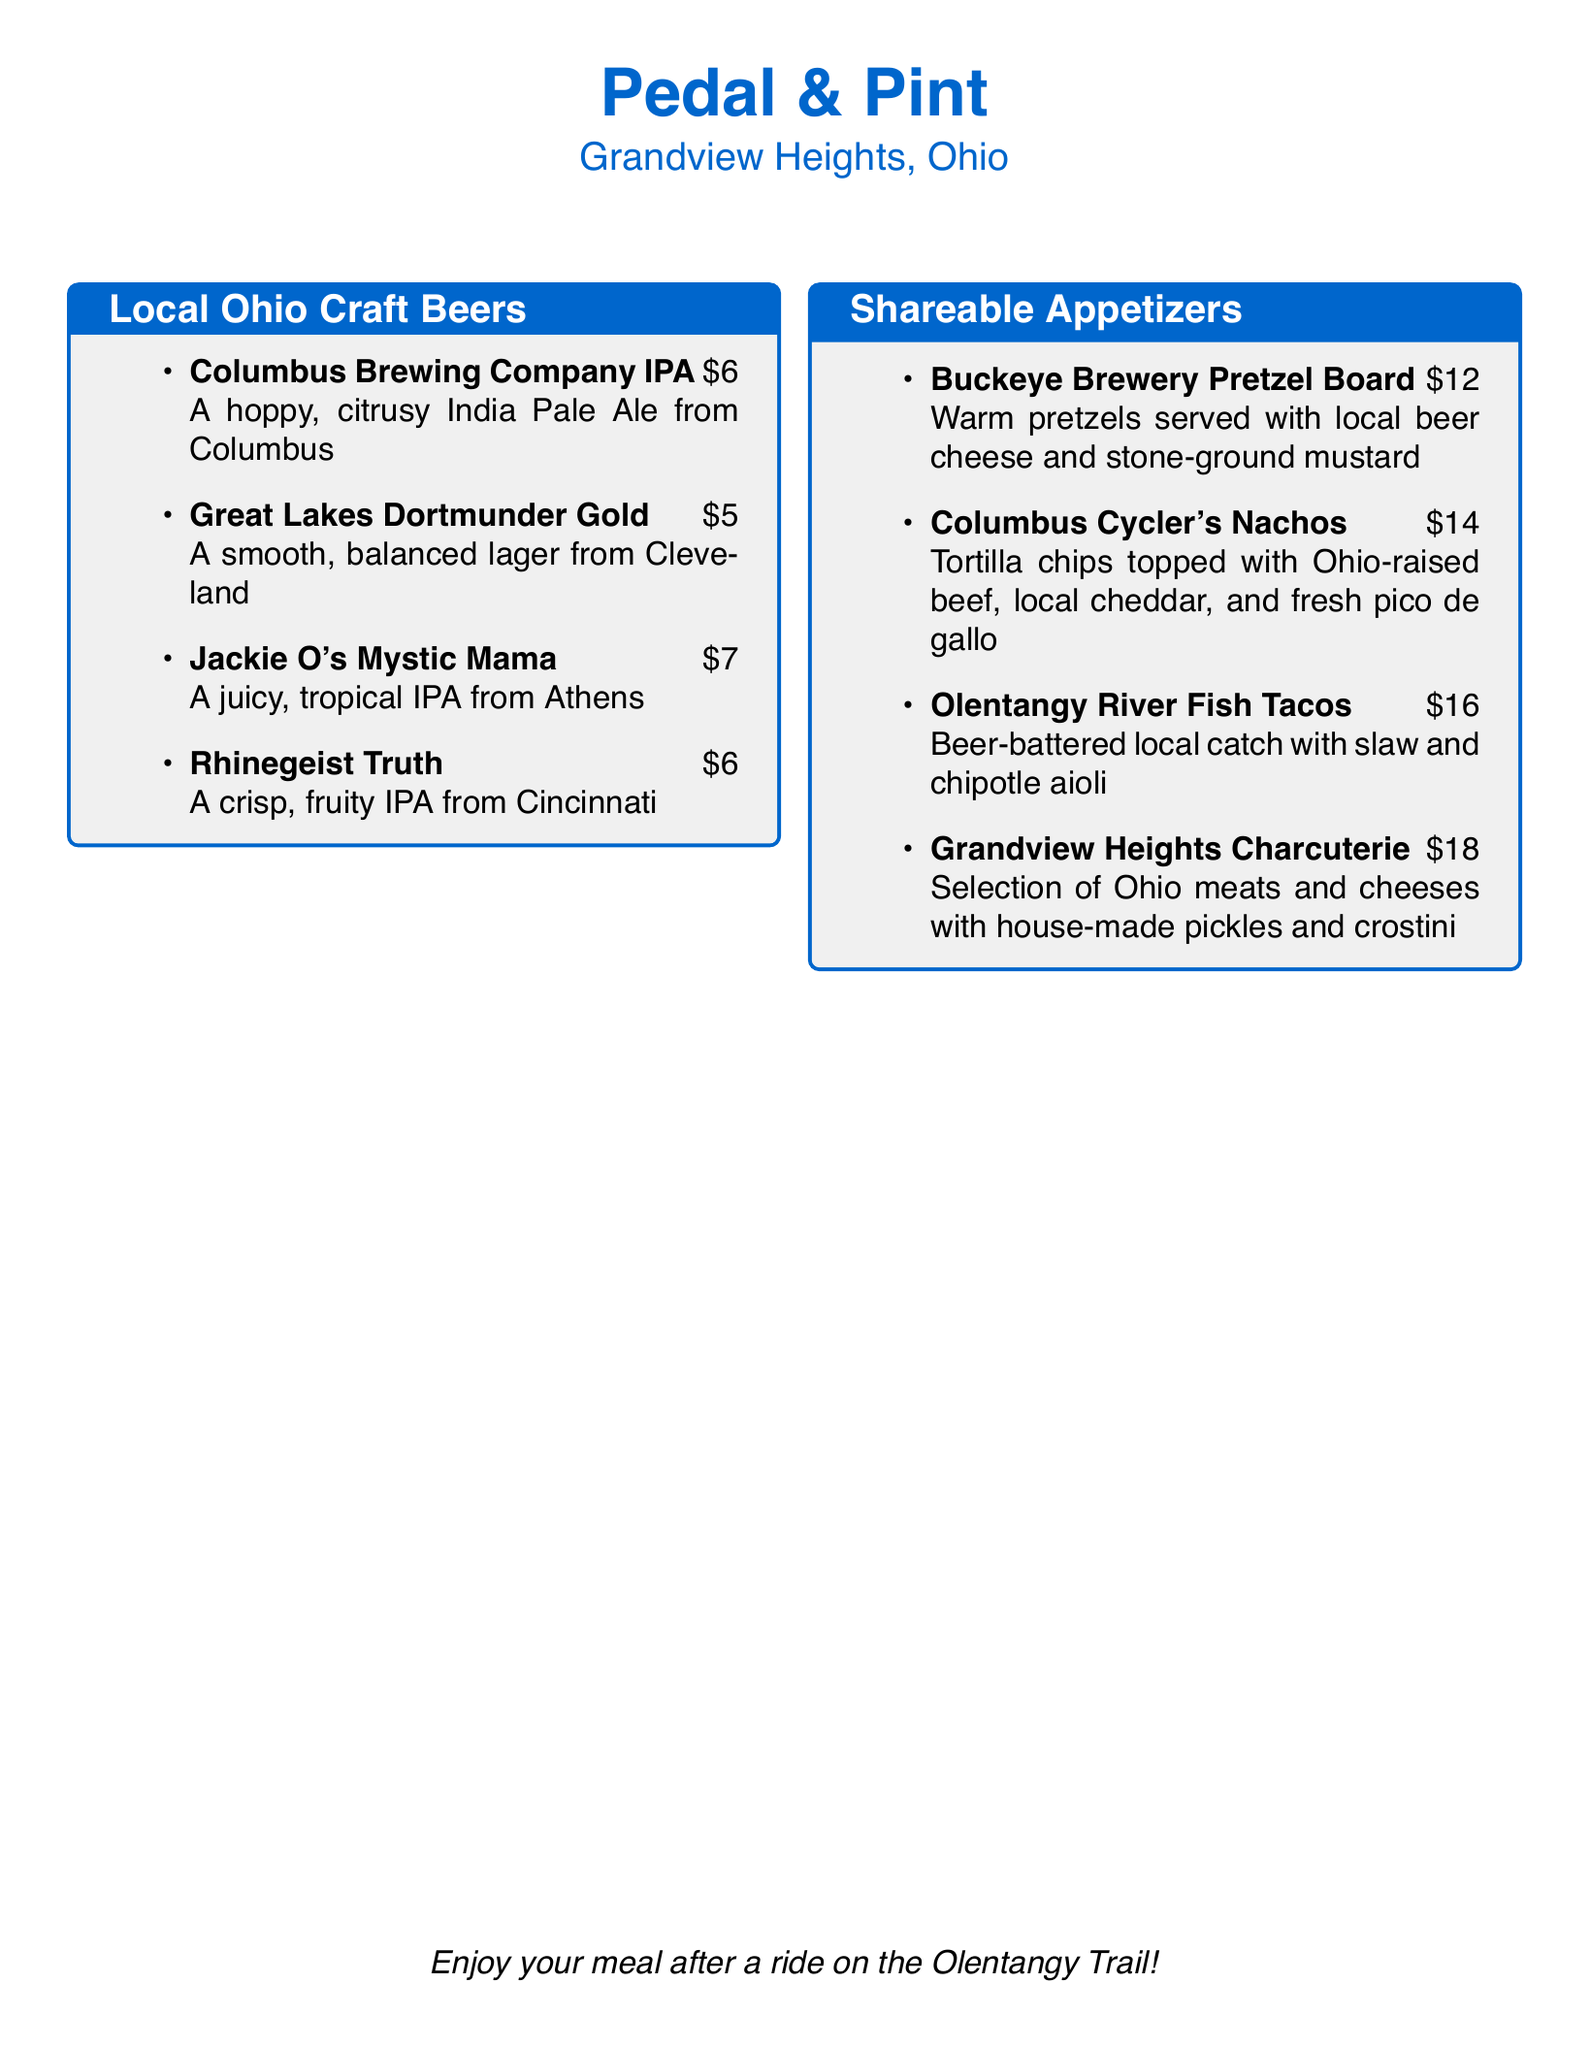What is the name of the first craft beer listed? The first craft beer listed in the menu is Columbus Brewing Company IPA.
Answer: Columbus Brewing Company IPA How much does the Great Lakes Dortmunder Gold cost? The menu states that the Great Lakes Dortmunder Gold is priced at $5.
Answer: $5 What is a main ingredient in the Columbus Cycler's Nachos? The nachos include Ohio-raised beef as a main ingredient.
Answer: Ohio-raised beef Which city is the Jackie O's Mystic Mama brewed in? The document specifies that Jackie O's Mystic Mama is brewed in Athens.
Answer: Athens How many shares of appetizers are listed on the menu? There are four shareable appetizers listed on the menu.
Answer: Four What type of beer is the Rhinegeist Truth? The document describes the Rhinegeist Truth as a fruity IPA.
Answer: Fruity IPA What is served with the Buckeye Brewery Pretzel Board? The pretzel board is served with local beer cheese and stone-ground mustard.
Answer: Local beer cheese and stone-ground mustard What is the total price of the Grandview Heights Charcuterie? The menu indicates that the Grandview Heights Charcuterie is priced at $18.
Answer: $18 Which drink option is available from Cincinnati? The Rhinegeist Truth is the drink option available from Cincinnati.
Answer: Rhinegeist Truth 